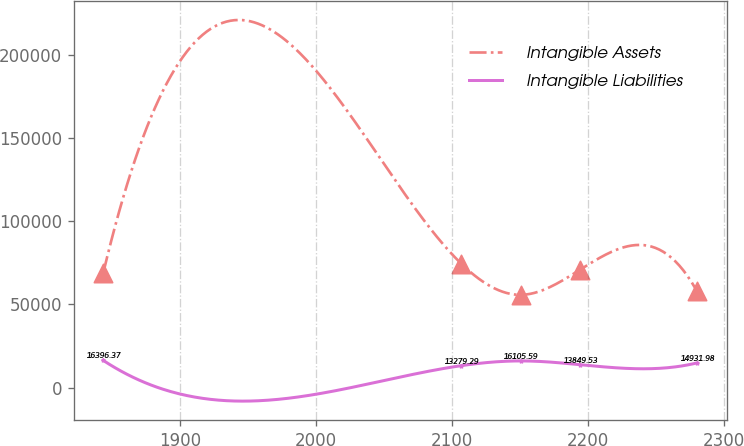Convert chart. <chart><loc_0><loc_0><loc_500><loc_500><line_chart><ecel><fcel>Intangible Assets<fcel>Intangible Liabilities<nl><fcel>1843.8<fcel>69033.3<fcel>16396.4<nl><fcel>2106.87<fcel>74416.9<fcel>13279.3<nl><fcel>2150.5<fcel>55784<fcel>16105.6<nl><fcel>2194.13<fcel>70896.6<fcel>13849.5<nl><fcel>2280.06<fcel>57794.8<fcel>14932<nl></chart> 